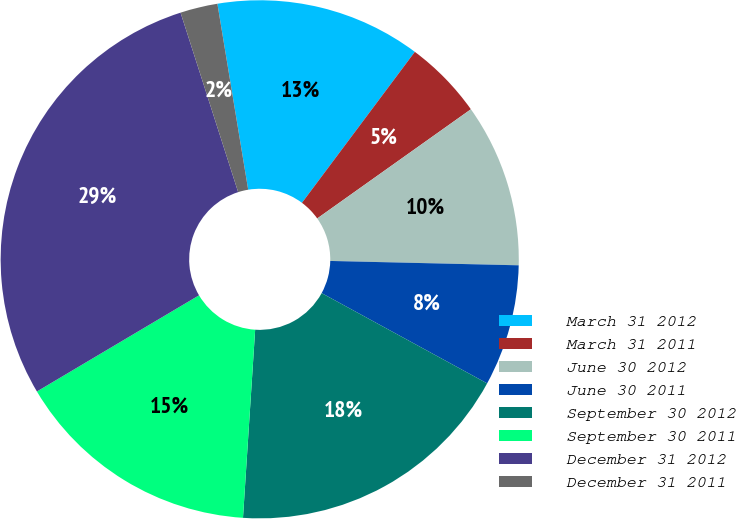Convert chart. <chart><loc_0><loc_0><loc_500><loc_500><pie_chart><fcel>March 31 2012<fcel>March 31 2011<fcel>June 30 2012<fcel>June 30 2011<fcel>September 30 2012<fcel>September 30 2011<fcel>December 31 2012<fcel>December 31 2011<nl><fcel>12.83%<fcel>4.95%<fcel>10.2%<fcel>7.58%<fcel>18.08%<fcel>15.45%<fcel>28.58%<fcel>2.33%<nl></chart> 